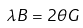Convert formula to latex. <formula><loc_0><loc_0><loc_500><loc_500>\lambda B = 2 \theta G</formula> 